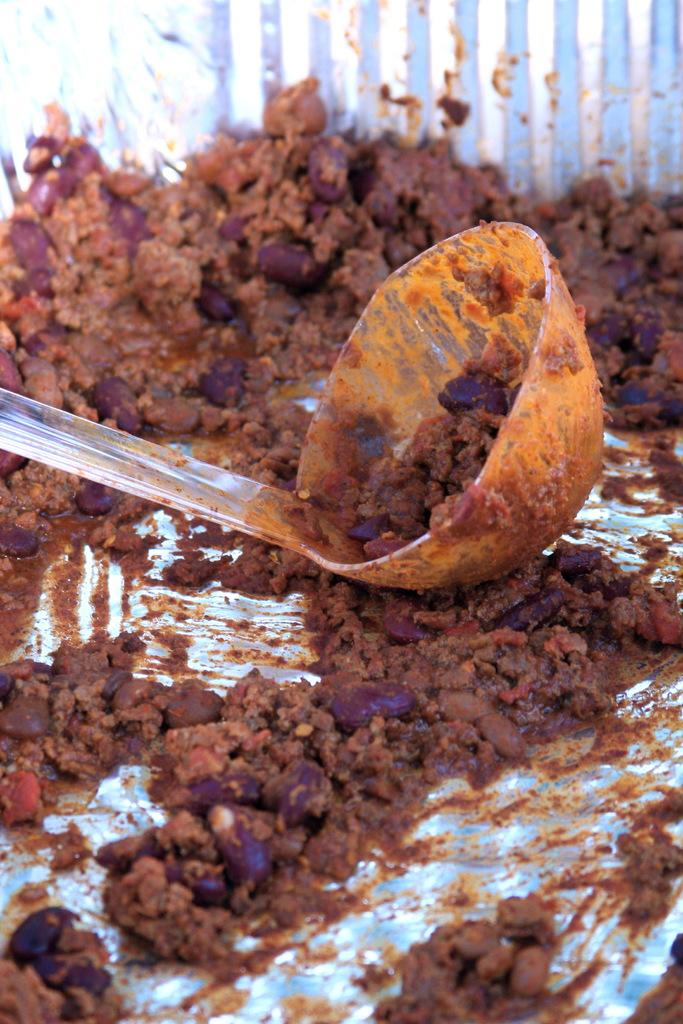What is the main object in the center of the image? There is a blue color object in the center of the image. What is inside the blue color object? The blue color object contains a big spoon. What else can be seen inside the blue color object? There are food items visible in the blue color object. How would you describe the background of the image? The background of the image is blurred. How does the yak contribute to the food items in the blue color object? There is no yak present in the image, so it cannot contribute to the food items in the blue color object. 